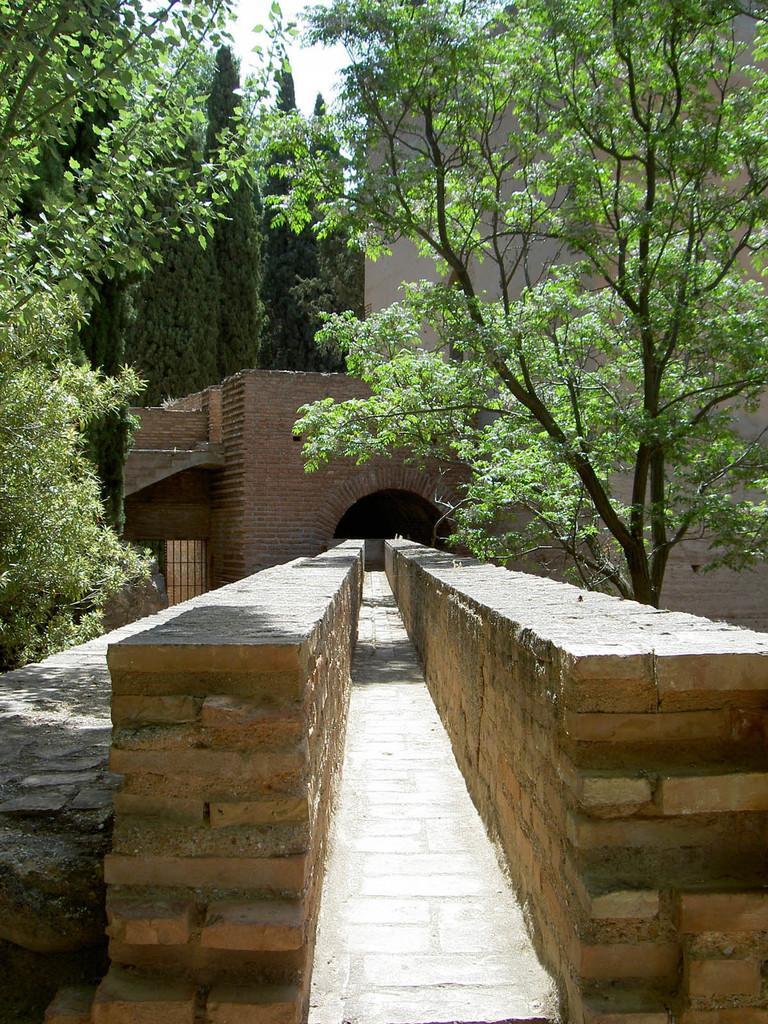Describe this image in one or two sentences. In this image I can see trees in green color, buildings in brown and cream color and the sky is in white color. 